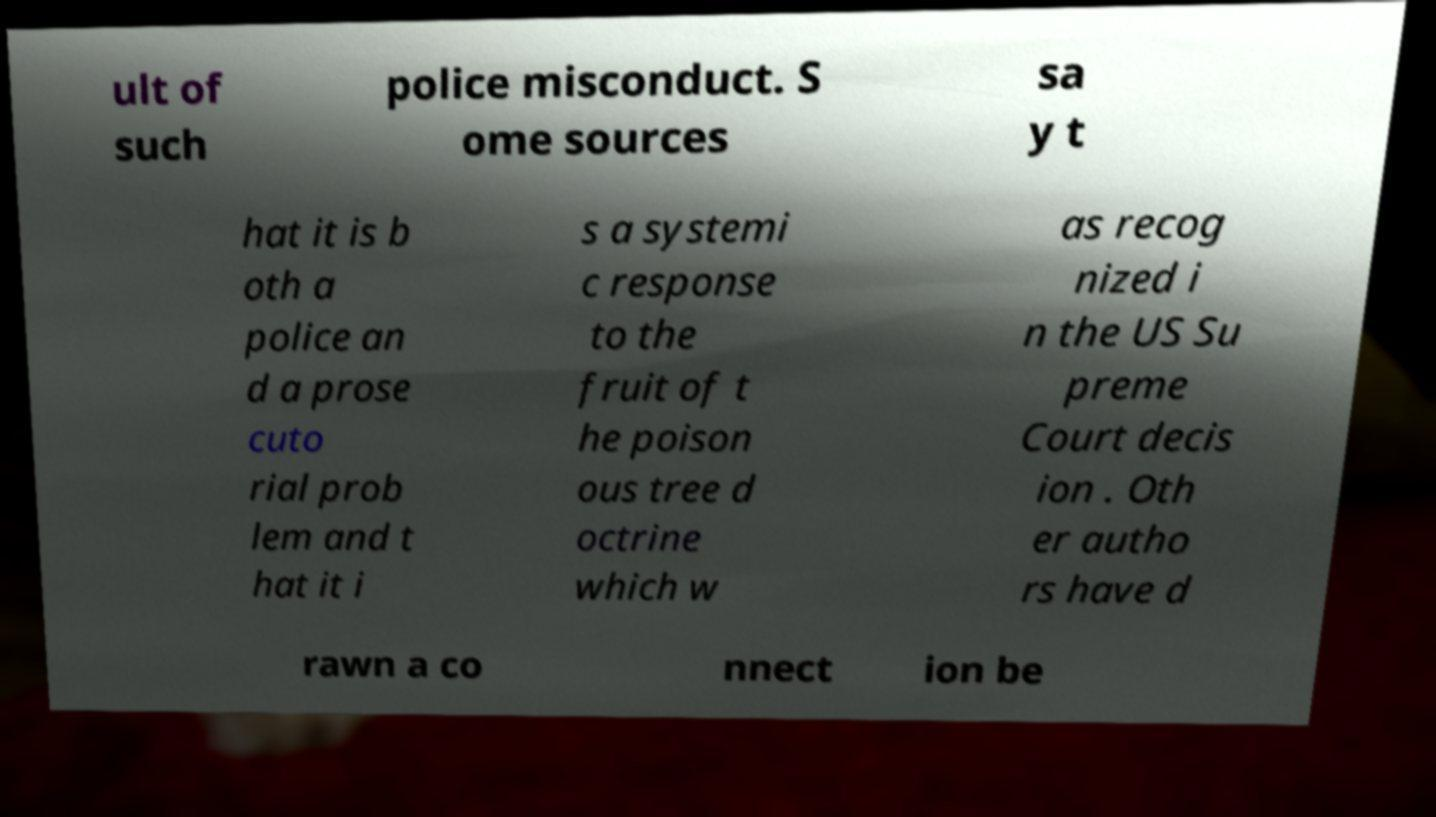Can you read and provide the text displayed in the image?This photo seems to have some interesting text. Can you extract and type it out for me? ult of such police misconduct. S ome sources sa y t hat it is b oth a police an d a prose cuto rial prob lem and t hat it i s a systemi c response to the fruit of t he poison ous tree d octrine which w as recog nized i n the US Su preme Court decis ion . Oth er autho rs have d rawn a co nnect ion be 